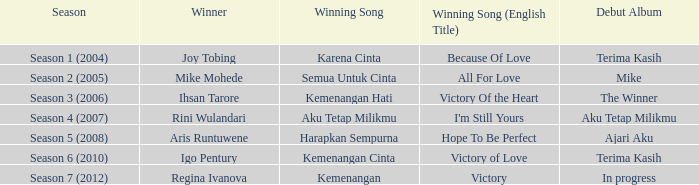What was the winning song that belonged to an ongoing debut album? Kemenangan. 